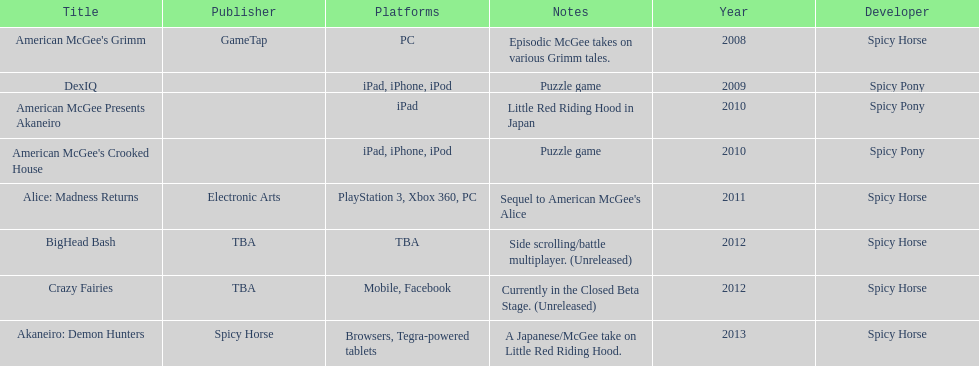What are the number of times an ipad was used as a platform? 3. 